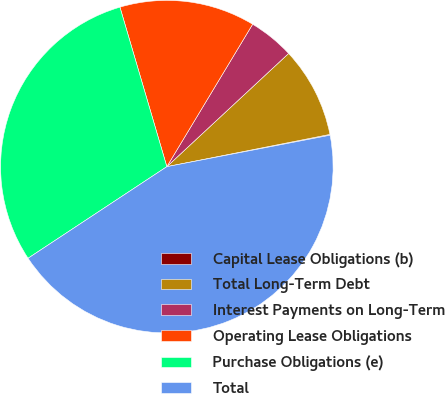Convert chart to OTSL. <chart><loc_0><loc_0><loc_500><loc_500><pie_chart><fcel>Capital Lease Obligations (b)<fcel>Total Long-Term Debt<fcel>Interest Payments on Long-Term<fcel>Operating Lease Obligations<fcel>Purchase Obligations (e)<fcel>Total<nl><fcel>0.08%<fcel>8.81%<fcel>4.45%<fcel>13.18%<fcel>29.73%<fcel>43.74%<nl></chart> 